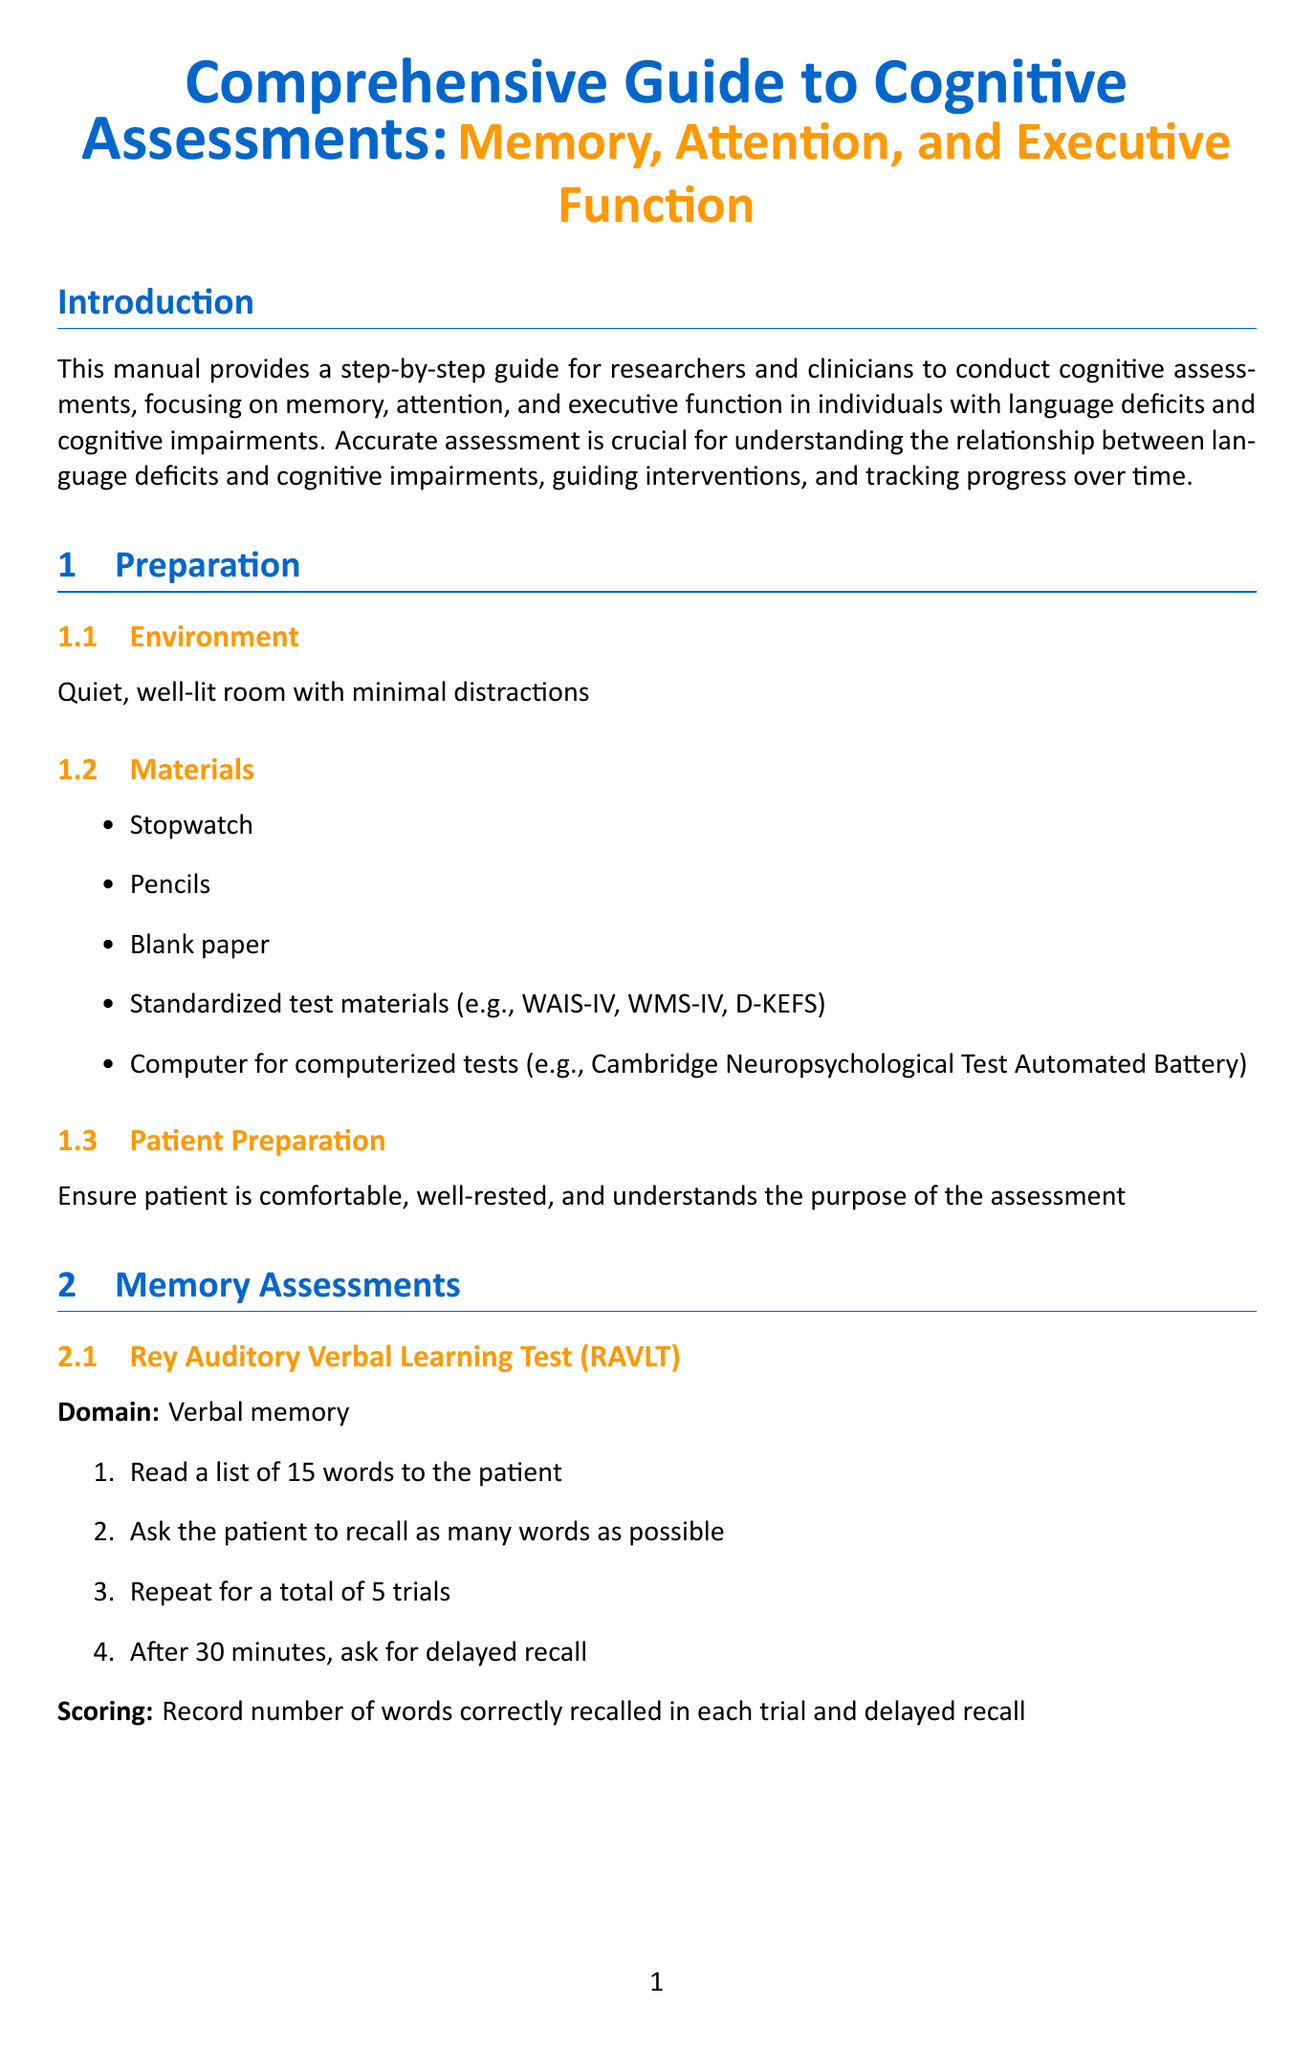What is the title of the manual? The title of the manual is stated at the beginning, focusing on comprehensive cognitive assessments.
Answer: Comprehensive Guide to Cognitive Assessments: Memory, Attention, and Executive Function What materials are needed for the assessments? A list of materials is provided under the preparation section that outlines what is required for cognitive assessments.
Answer: Stopwatch, Pencils, Blank paper, Standardized test materials, Computer for computerized tests What is the domain of the Rey Auditory Verbal Learning Test? The document specifies the domains for each test, including the Rey Auditory Verbal Learning Test.
Answer: Verbal memory How many trials are conducted in the Rey Auditory Verbal Learning Test? The procedure for the test indicates the number of trials to be completed.
Answer: 5 trials What is the main purpose of this manual? The introduction describes the purpose of the manual, outlining the target users and focus areas.
Answer: To provide a step-by-step guide for researchers and clinicians How should results be interpreted according to the guidelines? The interpretation section outlines specific guidelines for analyzing assessment results after they are obtained.
Answer: Compare results to age-appropriate norms What is recommended for follow-up after initial assessments? The follow-up section provides suggestions for actions to take after the assessments to ensure continued progress.
Answer: Schedule follow-up assessments Which test measures inhibition and cognitive control? The document details executive function assessments, specifying which tests are related to inhibition and cognitive control.
Answer: Stroop Color and Word Test What considerations should be given for language deficits during assessments? The special considerations section provides insights on how to address language deficits in patients.
Answer: Use nonverbal alternatives when appropriate 